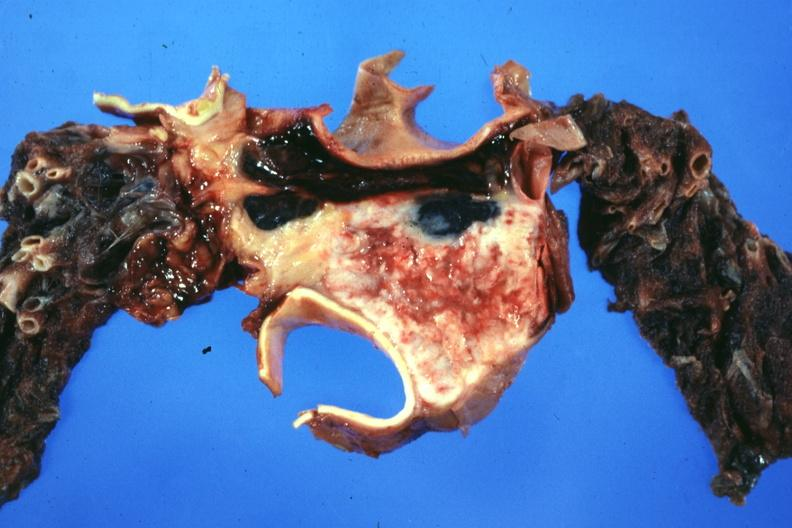s hematologic present?
Answer the question using a single word or phrase. Yes 